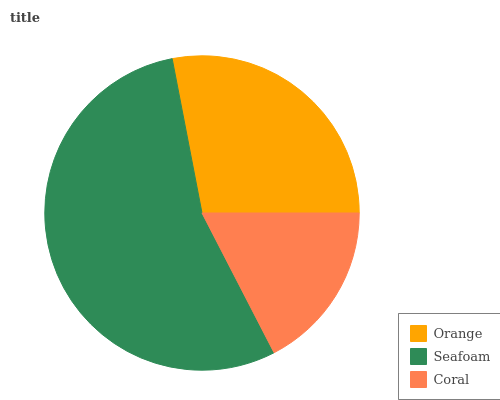Is Coral the minimum?
Answer yes or no. Yes. Is Seafoam the maximum?
Answer yes or no. Yes. Is Seafoam the minimum?
Answer yes or no. No. Is Coral the maximum?
Answer yes or no. No. Is Seafoam greater than Coral?
Answer yes or no. Yes. Is Coral less than Seafoam?
Answer yes or no. Yes. Is Coral greater than Seafoam?
Answer yes or no. No. Is Seafoam less than Coral?
Answer yes or no. No. Is Orange the high median?
Answer yes or no. Yes. Is Orange the low median?
Answer yes or no. Yes. Is Seafoam the high median?
Answer yes or no. No. Is Coral the low median?
Answer yes or no. No. 